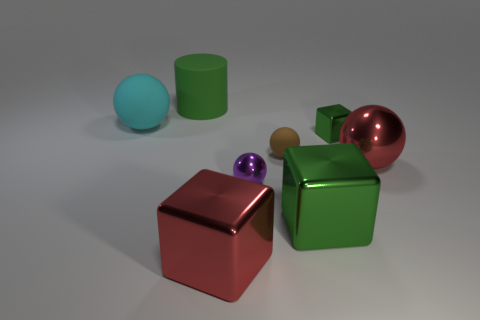Subtract all large metal blocks. How many blocks are left? 1 Subtract all red balls. How many balls are left? 3 Subtract all cylinders. How many objects are left? 7 Subtract all green cylinders. How many green cubes are left? 2 Subtract 1 balls. How many balls are left? 3 Add 1 purple metallic objects. How many objects exist? 9 Subtract 0 green balls. How many objects are left? 8 Subtract all blue balls. Subtract all purple cubes. How many balls are left? 4 Subtract all large brown matte blocks. Subtract all small rubber things. How many objects are left? 7 Add 8 cyan spheres. How many cyan spheres are left? 9 